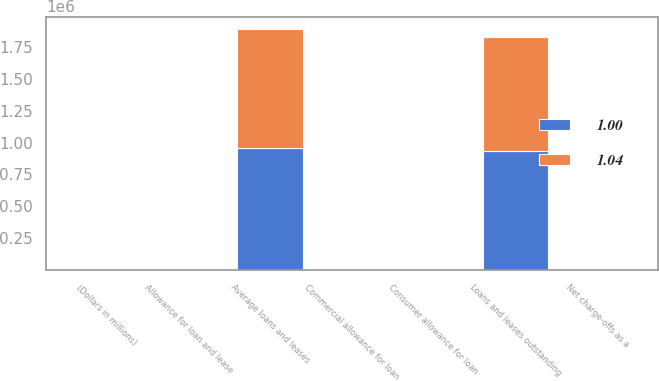<chart> <loc_0><loc_0><loc_500><loc_500><stacked_bar_chart><ecel><fcel>(Dollars in millions)<fcel>Loans and leases outstanding<fcel>Allowance for loan and lease<fcel>Consumer allowance for loan<fcel>Commercial allowance for loan<fcel>Average loans and leases<fcel>Net charge-offs as a<nl><fcel>1<fcel>2010<fcel>937119<fcel>136<fcel>5.4<fcel>2.44<fcel>954278<fcel>3.6<nl><fcel>1.04<fcel>2009<fcel>895192<fcel>111<fcel>4.81<fcel>2.96<fcel>941862<fcel>3.58<nl></chart> 